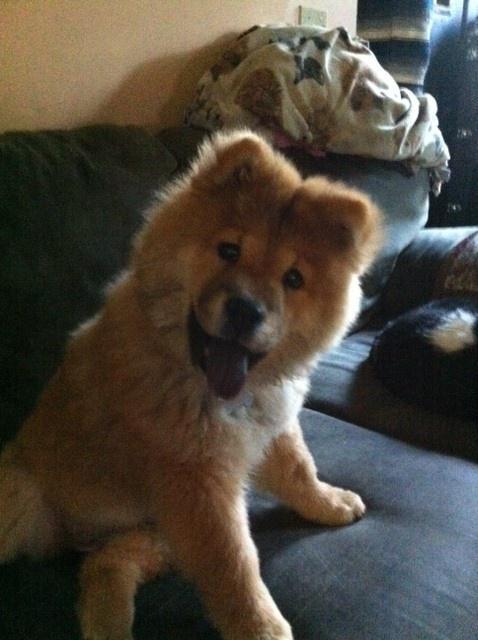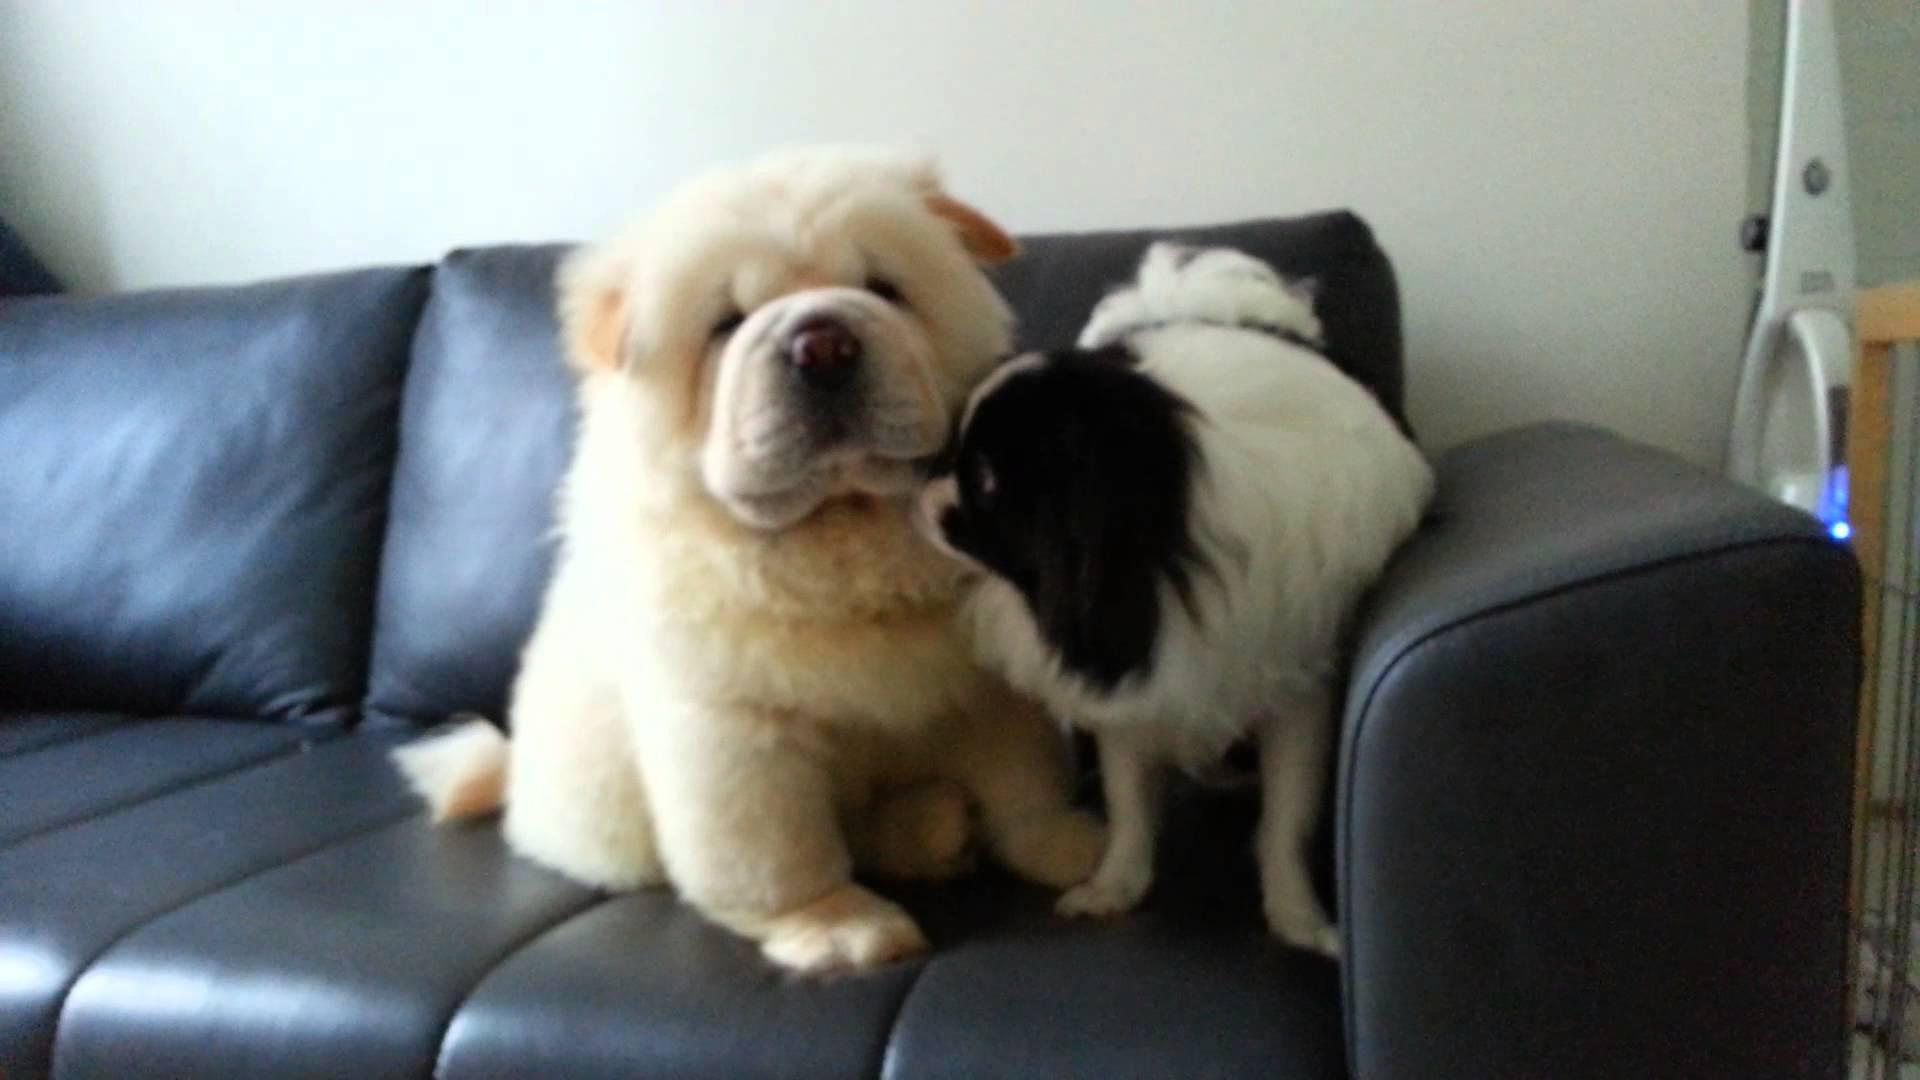The first image is the image on the left, the second image is the image on the right. Examine the images to the left and right. Is the description "Each image contains one dog, and the dog on the right is standing, while the dog on the left is reclining." accurate? Answer yes or no. No. 